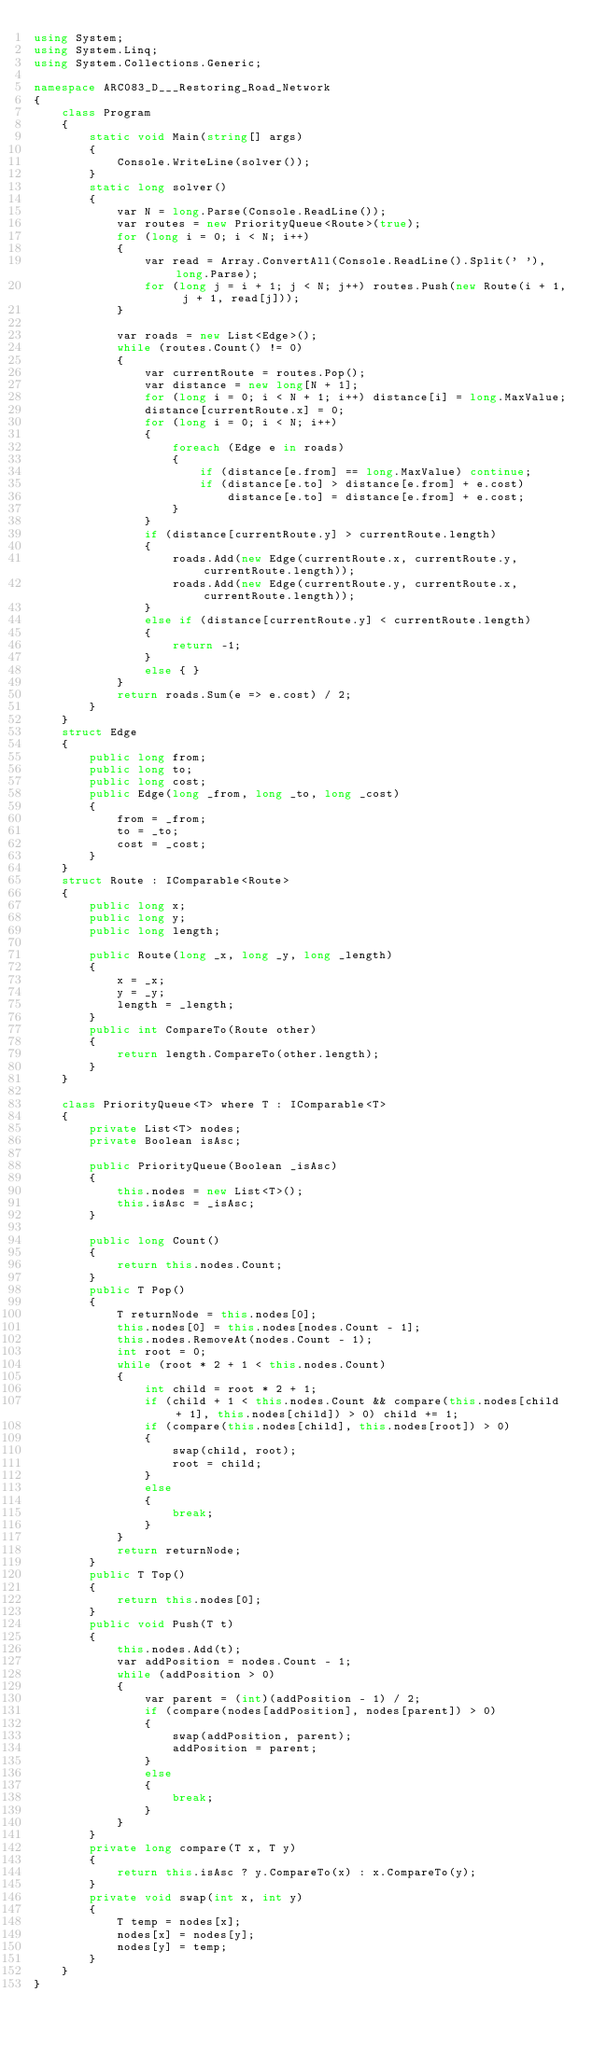<code> <loc_0><loc_0><loc_500><loc_500><_C#_>using System;
using System.Linq;
using System.Collections.Generic;

namespace ARC083_D___Restoring_Road_Network
{
    class Program
    {
        static void Main(string[] args)
        {
            Console.WriteLine(solver());
        }
        static long solver()
        {
            var N = long.Parse(Console.ReadLine());
            var routes = new PriorityQueue<Route>(true);
            for (long i = 0; i < N; i++)
            {
                var read = Array.ConvertAll(Console.ReadLine().Split(' '), long.Parse);
                for (long j = i + 1; j < N; j++) routes.Push(new Route(i + 1, j + 1, read[j]));
            }

            var roads = new List<Edge>();
            while (routes.Count() != 0)
            {
                var currentRoute = routes.Pop();
                var distance = new long[N + 1];
                for (long i = 0; i < N + 1; i++) distance[i] = long.MaxValue;
                distance[currentRoute.x] = 0;
                for (long i = 0; i < N; i++)
                {
                    foreach (Edge e in roads)
                    {
                        if (distance[e.from] == long.MaxValue) continue;
                        if (distance[e.to] > distance[e.from] + e.cost)
                            distance[e.to] = distance[e.from] + e.cost;
                    }
                }
                if (distance[currentRoute.y] > currentRoute.length)
                {
                    roads.Add(new Edge(currentRoute.x, currentRoute.y, currentRoute.length));
                    roads.Add(new Edge(currentRoute.y, currentRoute.x, currentRoute.length));
                }
                else if (distance[currentRoute.y] < currentRoute.length)
                {
                    return -1;
                }
                else { }
            }
            return roads.Sum(e => e.cost) / 2;
        }
    }
    struct Edge
    {
        public long from;
        public long to;
        public long cost;
        public Edge(long _from, long _to, long _cost)
        {
            from = _from;
            to = _to;
            cost = _cost;
        }
    }
    struct Route : IComparable<Route>
    {
        public long x;
        public long y;
        public long length;

        public Route(long _x, long _y, long _length)
        {
            x = _x;
            y = _y;
            length = _length;
        }
        public int CompareTo(Route other)
        {
            return length.CompareTo(other.length);
        }
    }

    class PriorityQueue<T> where T : IComparable<T>
    {
        private List<T> nodes;
        private Boolean isAsc;

        public PriorityQueue(Boolean _isAsc)
        {
            this.nodes = new List<T>();
            this.isAsc = _isAsc;
        }

        public long Count()
        {
            return this.nodes.Count;
        }
        public T Pop()
        {
            T returnNode = this.nodes[0];
            this.nodes[0] = this.nodes[nodes.Count - 1];
            this.nodes.RemoveAt(nodes.Count - 1);
            int root = 0;
            while (root * 2 + 1 < this.nodes.Count)
            {
                int child = root * 2 + 1;
                if (child + 1 < this.nodes.Count && compare(this.nodes[child + 1], this.nodes[child]) > 0) child += 1;
                if (compare(this.nodes[child], this.nodes[root]) > 0)
                {
                    swap(child, root);
                    root = child;
                }
                else
                {
                    break;
                }
            }
            return returnNode;
        }
        public T Top()
        {
            return this.nodes[0];
        }
        public void Push(T t)
        {
            this.nodes.Add(t);
            var addPosition = nodes.Count - 1;
            while (addPosition > 0)
            {
                var parent = (int)(addPosition - 1) / 2;
                if (compare(nodes[addPosition], nodes[parent]) > 0)
                {
                    swap(addPosition, parent);
                    addPosition = parent;
                }
                else
                {
                    break;
                }
            }
        }
        private long compare(T x, T y)
        {
            return this.isAsc ? y.CompareTo(x) : x.CompareTo(y);
        }
        private void swap(int x, int y)
        {
            T temp = nodes[x];
            nodes[x] = nodes[y];
            nodes[y] = temp;
        }
    }
}
</code> 